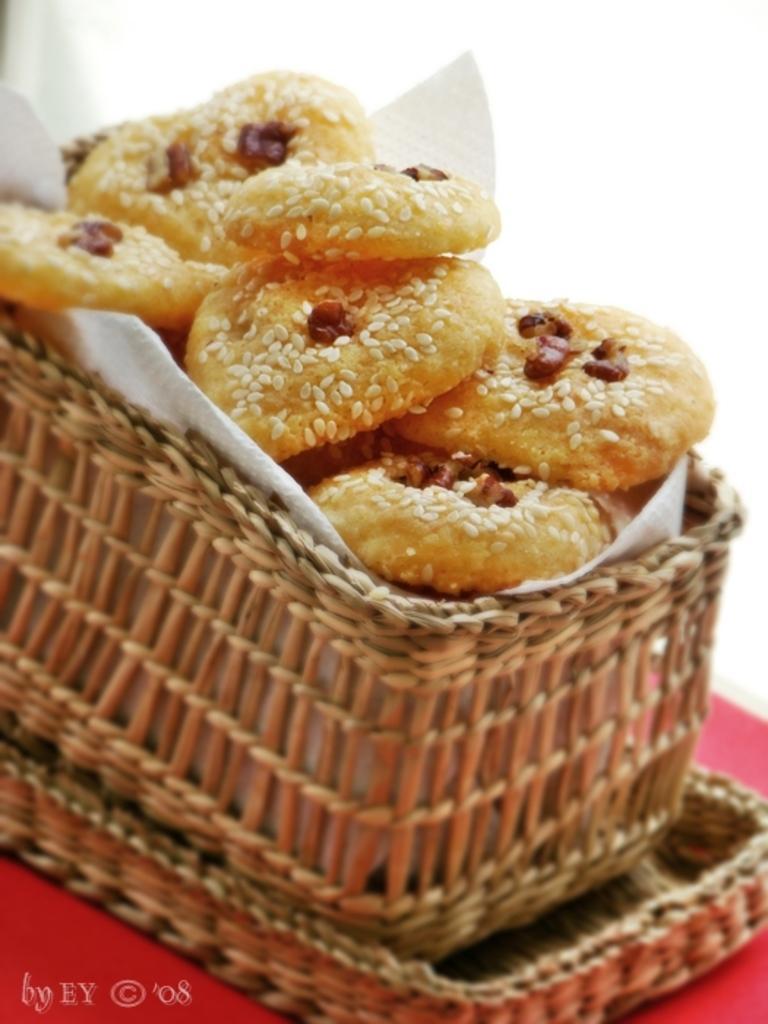Could you give a brief overview of what you see in this image? In this picture we can see food and a tissue in the basket and the basket is on the red object. Behind the basket, there is a white background. 